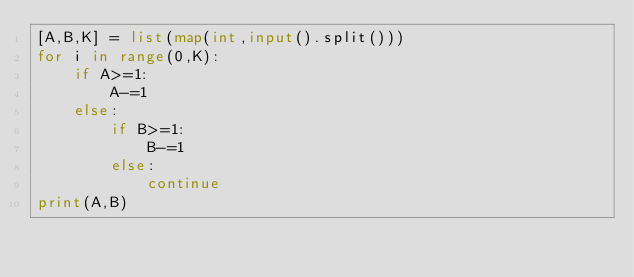Convert code to text. <code><loc_0><loc_0><loc_500><loc_500><_Python_>[A,B,K] = list(map(int,input().split()))
for i in range(0,K):
    if A>=1:
        A-=1
    else:
        if B>=1:
            B-=1
        else:
            continue
print(A,B)</code> 